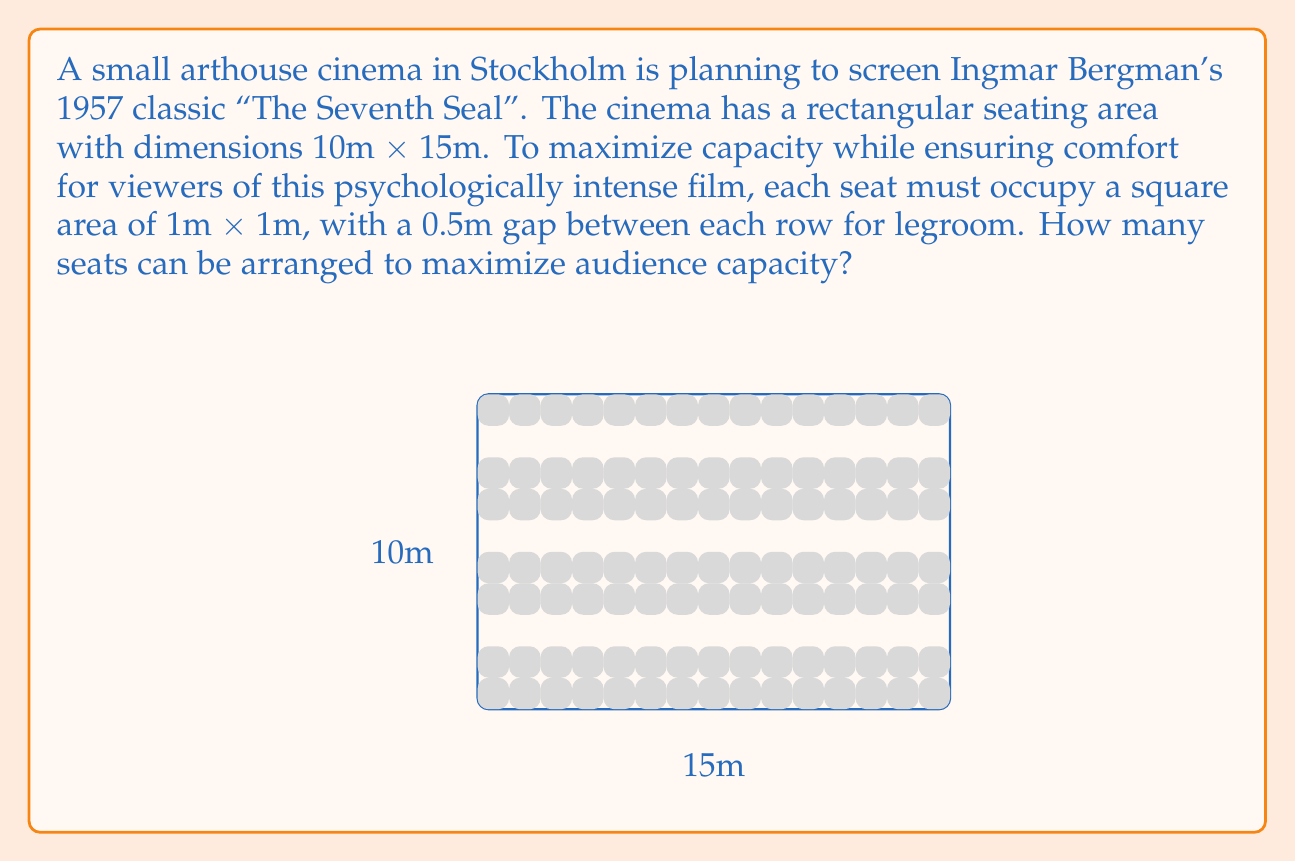Teach me how to tackle this problem. Let's approach this step-by-step:

1) First, we need to determine how many rows of seats we can fit:
   - The total height is 10m
   - Each row takes 1m for the seat + 0.5m for legroom = 1.5m
   - Number of rows = $\lfloor \frac{10}{1.5} \rfloor = 6$ rows
   (We use the floor function as we can't have a partial row)

2) Now, let's calculate how many seats we can fit in each row:
   - The width is 15m
   - Each seat is 1m wide
   - Seats per row = 15

3) To calculate the total number of seats:
   - Total seats = Rows × Seats per row
   - Total seats = $6 \times 15 = 90$

This arrangement maximizes the use of space while maintaining the required comfort for viewers.
Answer: 90 seats 